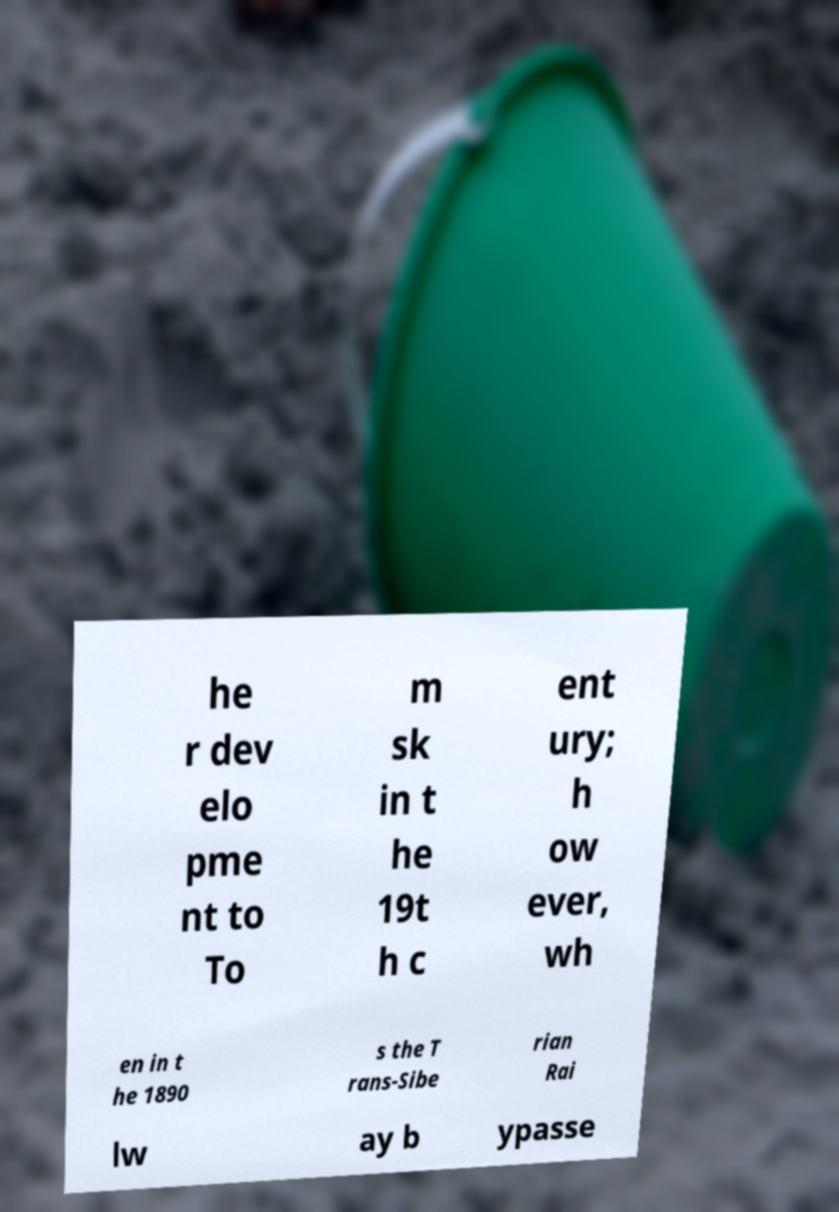There's text embedded in this image that I need extracted. Can you transcribe it verbatim? he r dev elo pme nt to To m sk in t he 19t h c ent ury; h ow ever, wh en in t he 1890 s the T rans-Sibe rian Rai lw ay b ypasse 